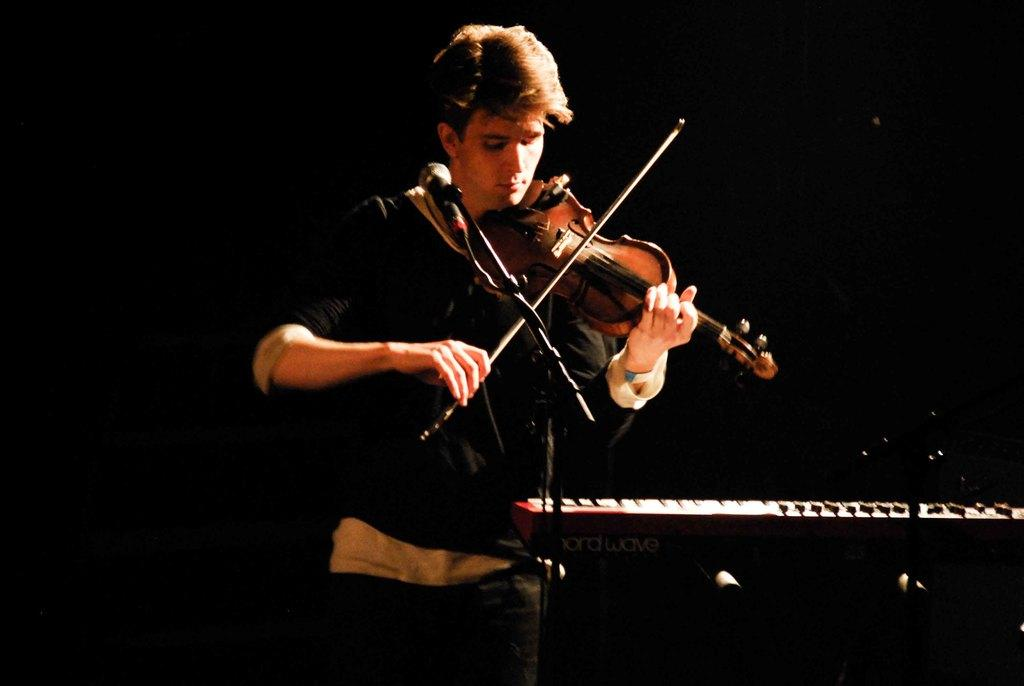What is the person in the image doing? The person is playing a violin in the image. What is the person using to amplify their sound? The person is behind a microphone. Can you describe the musical instrument on the right side of the image? Unfortunately, there is no information about a musical instrument on the right side of the image. What type of jam is being served on the volleyball in the image? There is no volleyball or jam present in the image. Can you describe the woman playing the violin in the image? There is no woman mentioned in the provided facts; the person playing the violin is not described as male or female. 